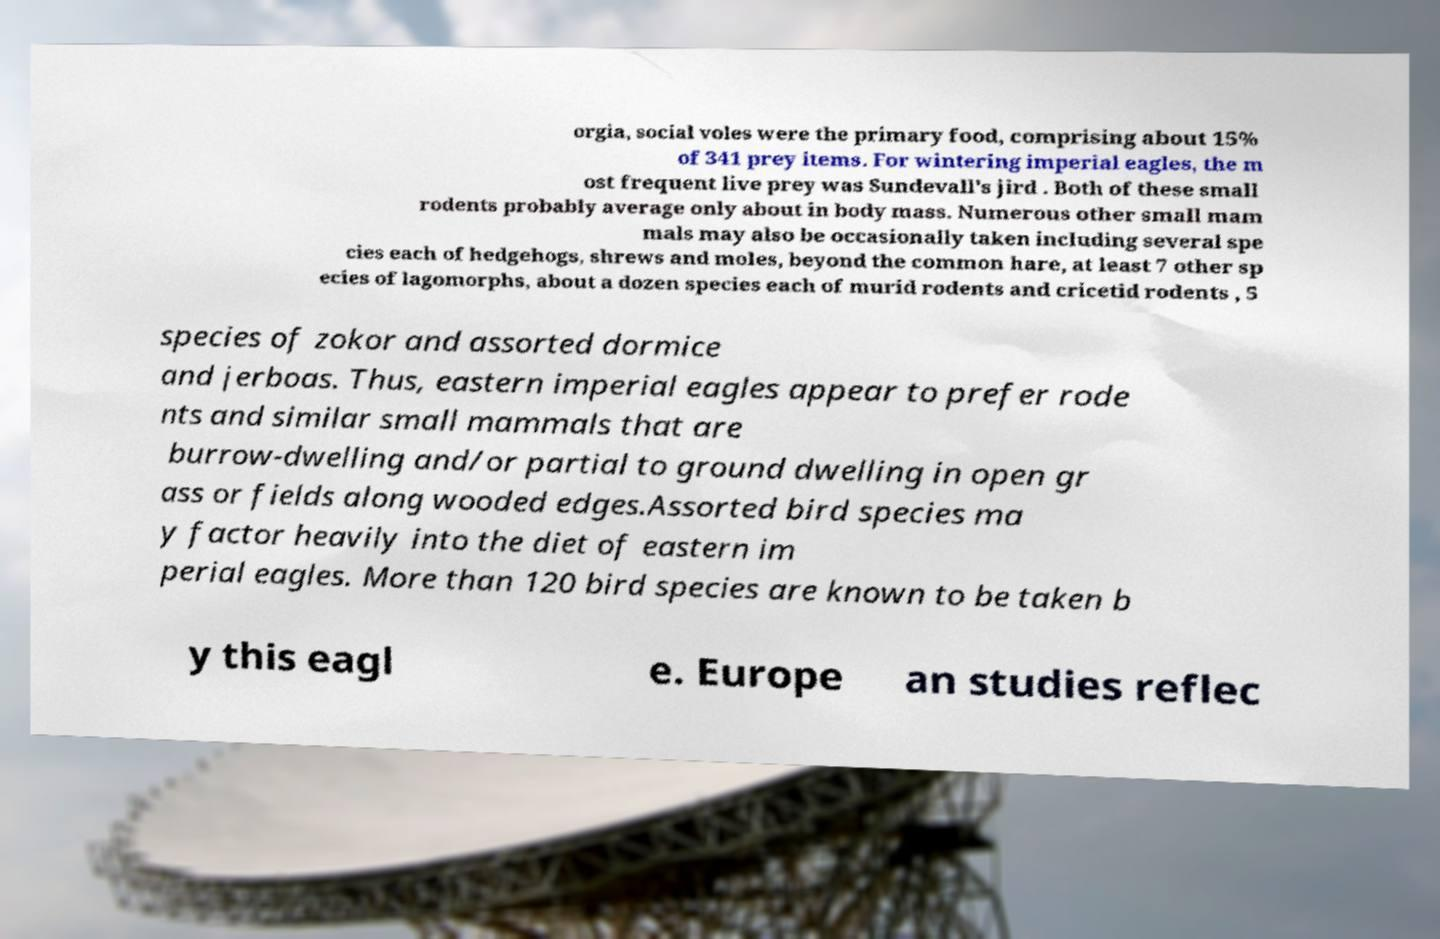There's text embedded in this image that I need extracted. Can you transcribe it verbatim? orgia, social voles were the primary food, comprising about 15% of 341 prey items. For wintering imperial eagles, the m ost frequent live prey was Sundevall's jird . Both of these small rodents probably average only about in body mass. Numerous other small mam mals may also be occasionally taken including several spe cies each of hedgehogs, shrews and moles, beyond the common hare, at least 7 other sp ecies of lagomorphs, about a dozen species each of murid rodents and cricetid rodents , 5 species of zokor and assorted dormice and jerboas. Thus, eastern imperial eagles appear to prefer rode nts and similar small mammals that are burrow-dwelling and/or partial to ground dwelling in open gr ass or fields along wooded edges.Assorted bird species ma y factor heavily into the diet of eastern im perial eagles. More than 120 bird species are known to be taken b y this eagl e. Europe an studies reflec 